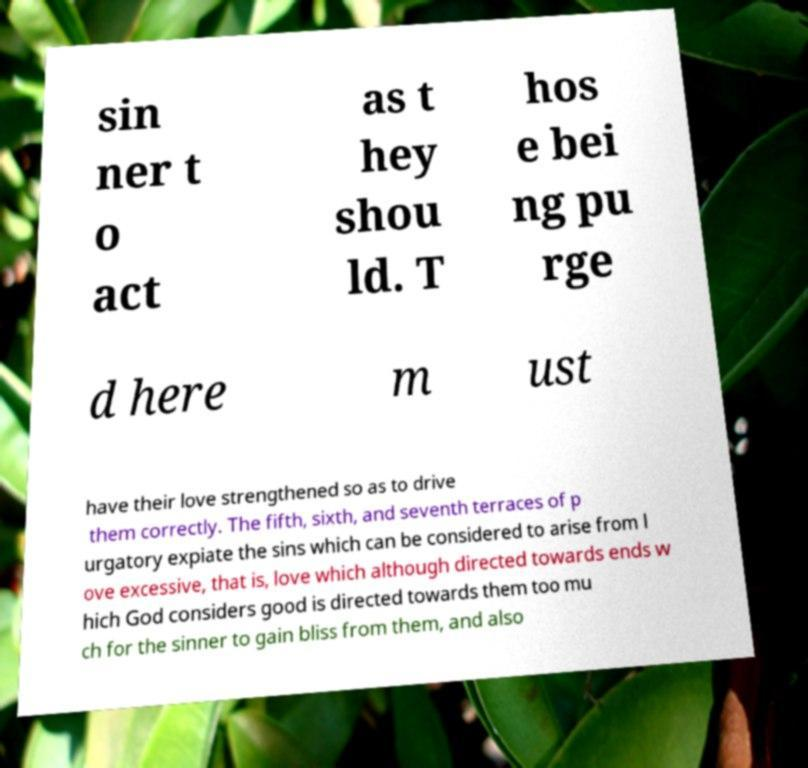I need the written content from this picture converted into text. Can you do that? sin ner t o act as t hey shou ld. T hos e bei ng pu rge d here m ust have their love strengthened so as to drive them correctly. The fifth, sixth, and seventh terraces of p urgatory expiate the sins which can be considered to arise from l ove excessive, that is, love which although directed towards ends w hich God considers good is directed towards them too mu ch for the sinner to gain bliss from them, and also 